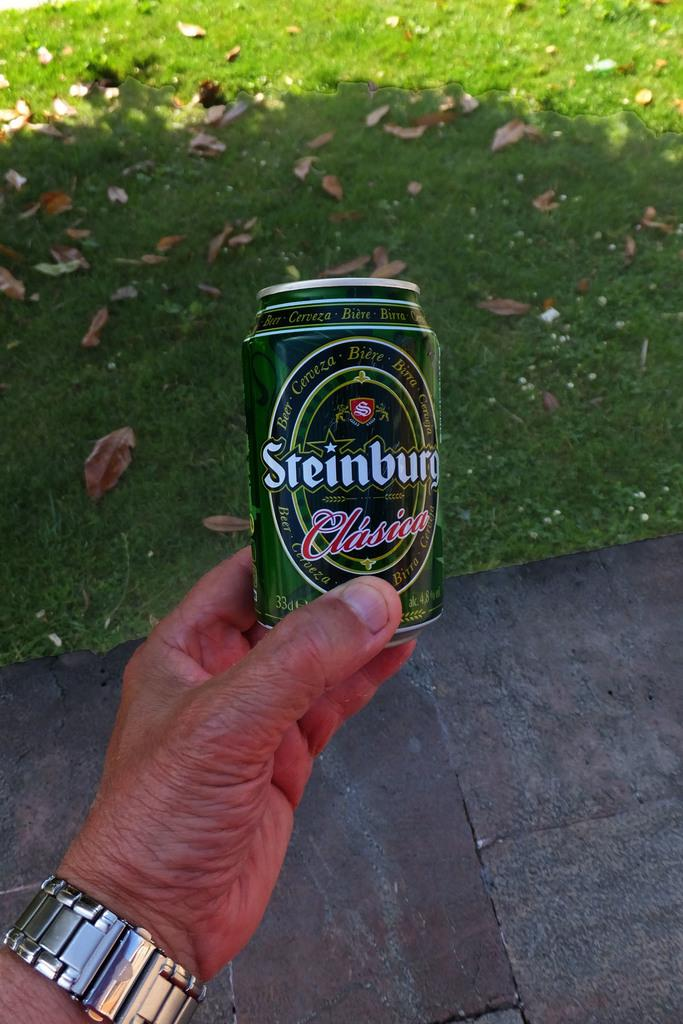<image>
Render a clear and concise summary of the photo. Someone is holding out a can of Steinburg Clasica. 